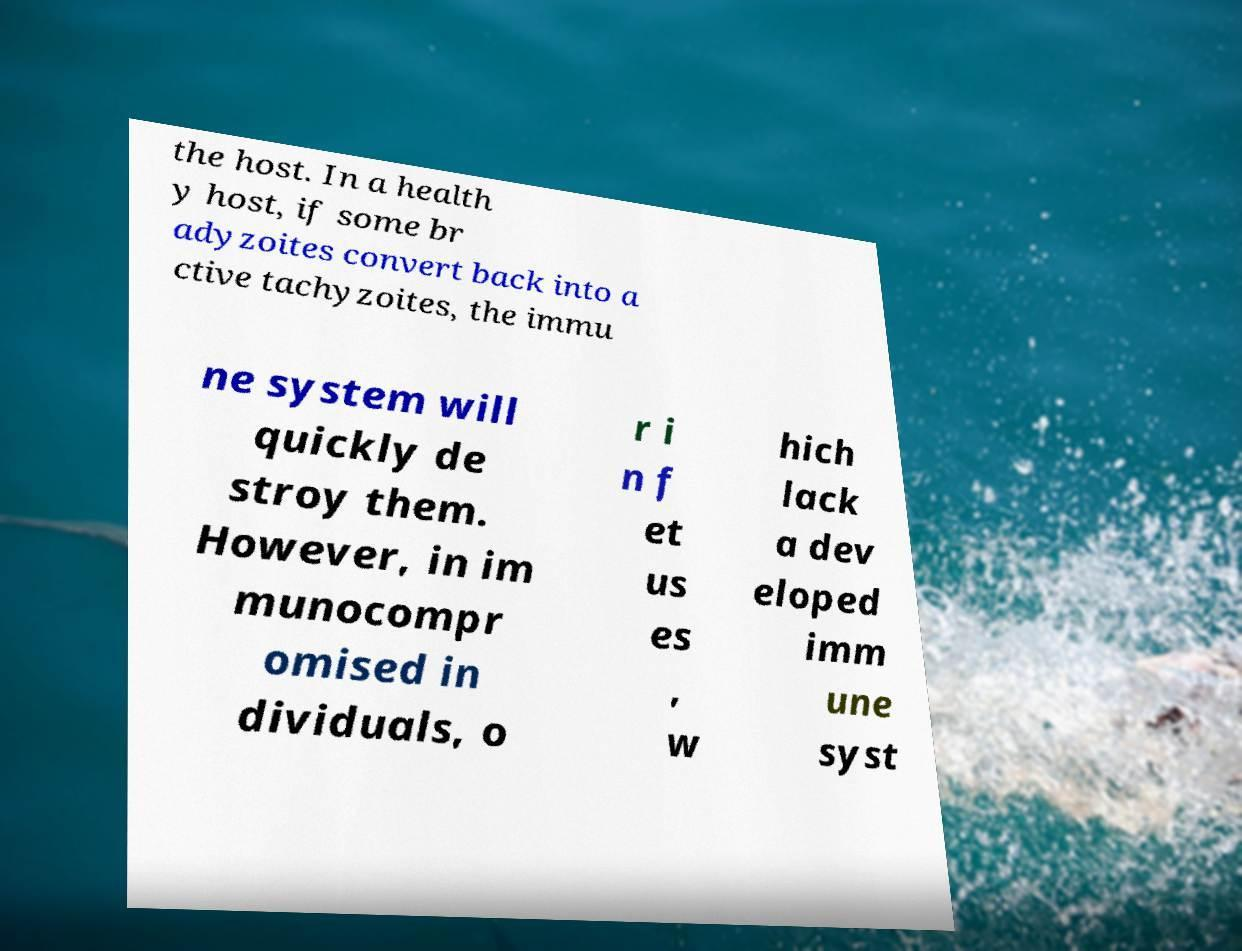For documentation purposes, I need the text within this image transcribed. Could you provide that? the host. In a health y host, if some br adyzoites convert back into a ctive tachyzoites, the immu ne system will quickly de stroy them. However, in im munocompr omised in dividuals, o r i n f et us es , w hich lack a dev eloped imm une syst 